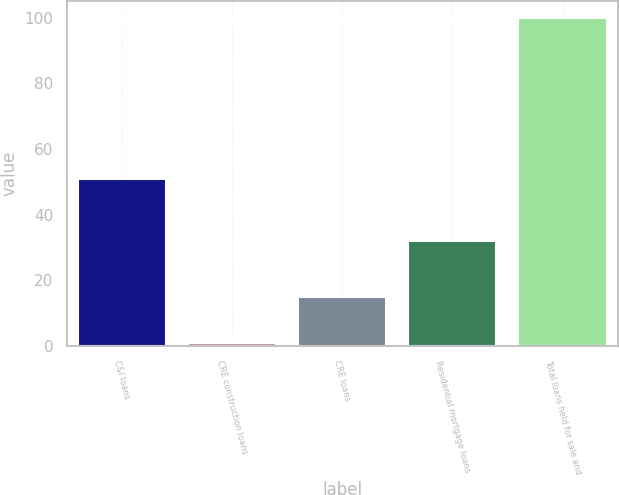Convert chart. <chart><loc_0><loc_0><loc_500><loc_500><bar_chart><fcel>C&I loans<fcel>CRE construction loans<fcel>CRE loans<fcel>Residential mortgage loans<fcel>Total loans held for sale and<nl><fcel>51<fcel>1<fcel>15<fcel>32<fcel>100<nl></chart> 